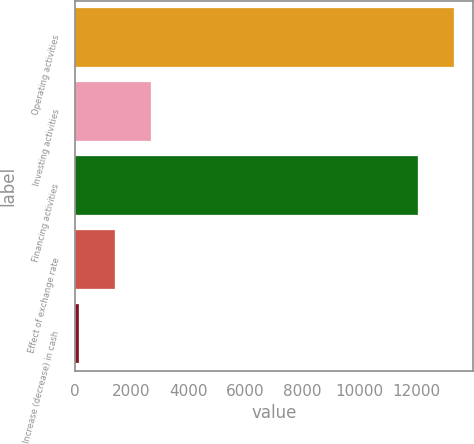Convert chart to OTSL. <chart><loc_0><loc_0><loc_500><loc_500><bar_chart><fcel>Operating activities<fcel>Investing activities<fcel>Financing activities<fcel>Effect of exchange rate<fcel>Increase (decrease) in cash<nl><fcel>13324.9<fcel>2672.8<fcel>12061<fcel>1408.9<fcel>145<nl></chart> 